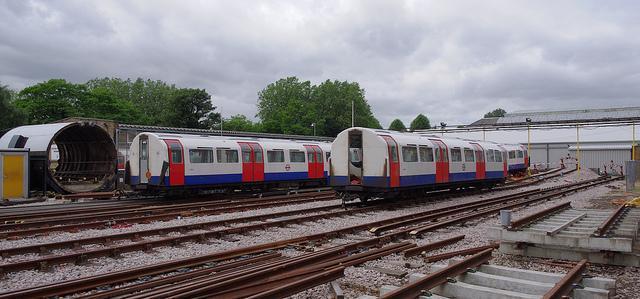How many trains can you see?
Give a very brief answer. 2. 